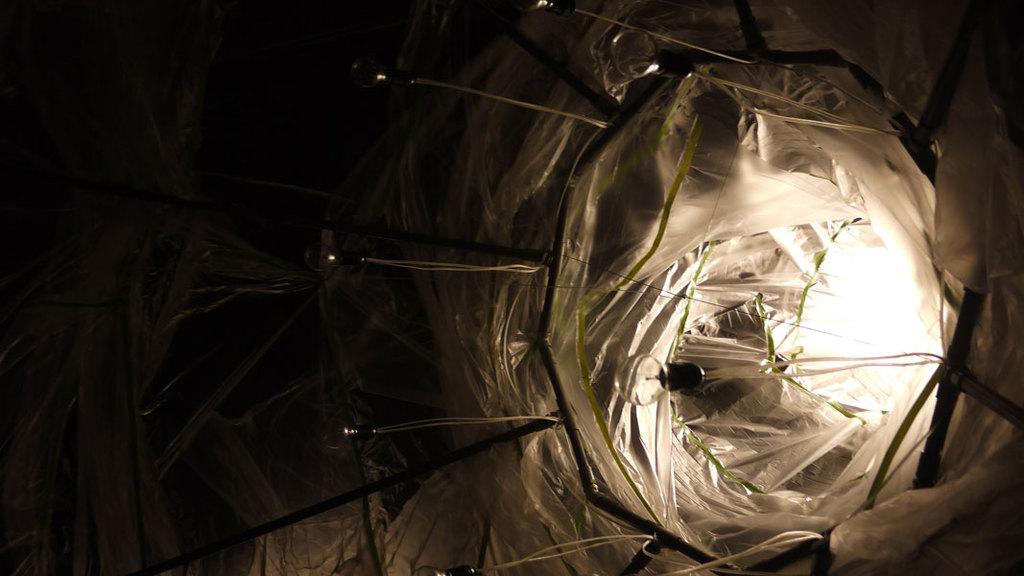Describe this image in one or two sentences. In this image we can see decorative lights, small rods and there is a cover on them and we can see a bulb and light. 